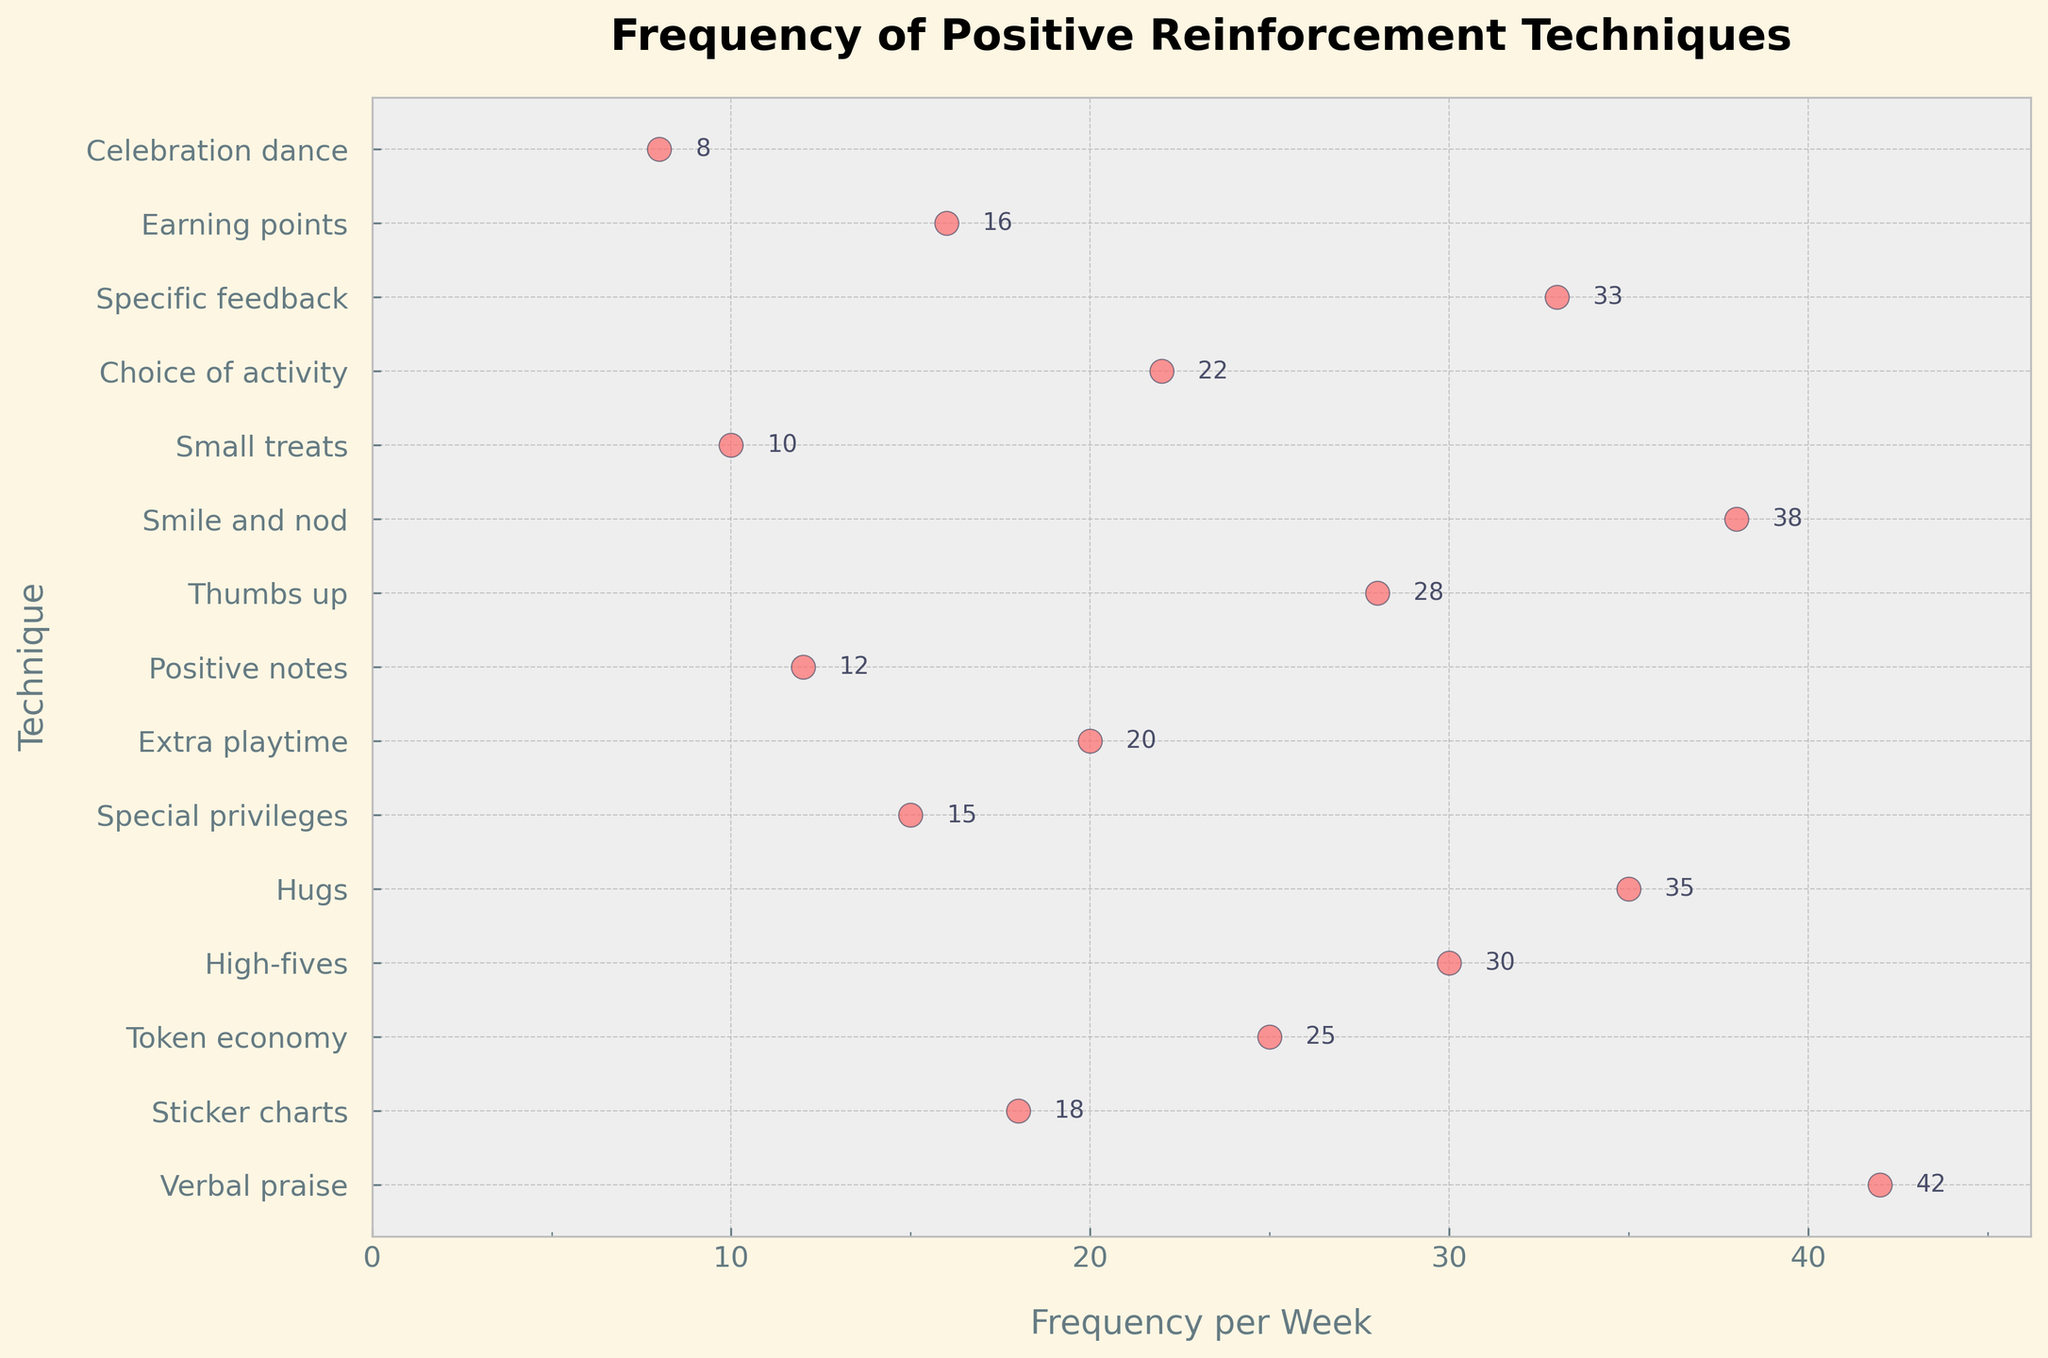What is the title of the plot? The title is typically found at the top of the plot and provides a high-level summary of what the plot is about. In this case, the title is "Frequency of Positive Reinforcement Techniques".
Answer: Frequency of Positive Reinforcement Techniques How many reinforcement techniques are depicted in the plot? Count the number of unique reinforcement techniques listed on the y-axis.
Answer: 15 Which technique is used the most frequently? Identify the technique with the highest frequency on the x-axis. The scatter plot shows "Verbal praise" with the highest frequency.
Answer: Verbal praise What is the least used technique? The technique with the lowest frequency value on the x-axis is "Celebration dance" with a frequency of 8.
Answer: Celebration dance What is the average frequency of using "Token economy" and "High-fives"? Add the frequencies of "Token economy" (25) and "High-fives" (30), then divide by 2 to get the average. (25 + 30) / 2 = 27.5
Answer: 27.5 Which technique is used more frequently: "Sticker charts" or "Extra playtime"? Compare the frequency values of "Sticker charts" (18) and "Extra playtime" (20). "Extra playtime" has a higher frequency.
Answer: Extra playtime What is the range of the frequencies shown in the plot? Subtract the lowest frequency value (8 for "Celebration dance") from the highest frequency value (42 for "Verbal praise"). Range = 42 - 8 = 34
Answer: 34 What is the median frequency of the techniques used? List and sort all frequency values. The median is the middle value in this sorted list. Sorted frequencies: 8, 10, 12, 15, 16, 18, 20, 22, 25, 28, 30, 33, 35, 38, 42. The median, being the 8th value, is 22.
Answer: 22 Is "Hugs" used more or less frequently than "Specific feedback"? Compare the frequency values of "Hugs" (35) to "Specific feedback" (33). "Hugs" are used more frequently.
Answer: More Which techniques have a frequency of 30 or more per week? Identify all techniques with a frequency value of 30 or higher by checking the plot. Techniques: "High-fives" (30), "Hugs" (35), "Smile and nod" (38), "Verbal praise" (42), "Specific feedback" (33).
Answer: High-fives, Hugs, Smile and nod, Verbal praise, Specific feedback 